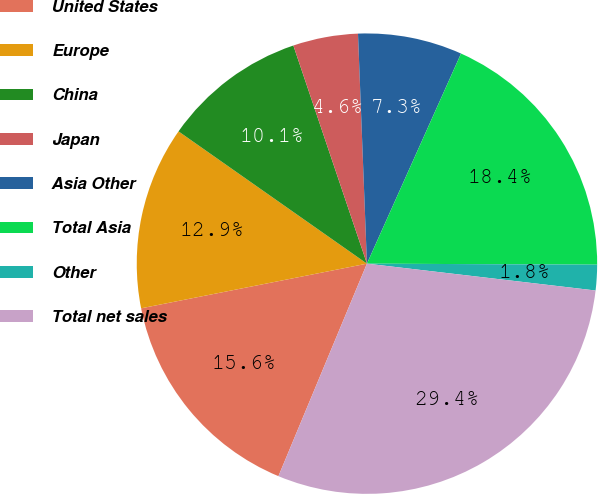<chart> <loc_0><loc_0><loc_500><loc_500><pie_chart><fcel>United States<fcel>Europe<fcel>China<fcel>Japan<fcel>Asia Other<fcel>Total Asia<fcel>Other<fcel>Total net sales<nl><fcel>15.61%<fcel>12.85%<fcel>10.08%<fcel>4.56%<fcel>7.32%<fcel>18.37%<fcel>1.79%<fcel>29.42%<nl></chart> 